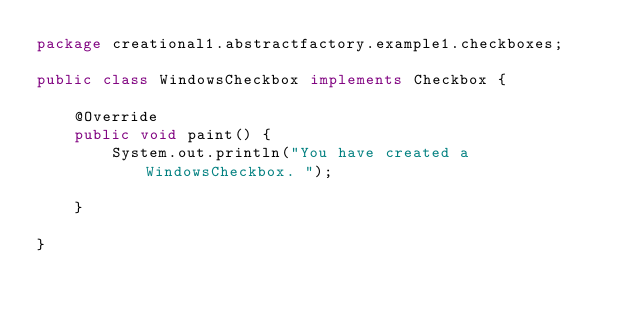Convert code to text. <code><loc_0><loc_0><loc_500><loc_500><_Java_>package creational1.abstractfactory.example1.checkboxes;

public class WindowsCheckbox implements Checkbox {

	@Override
	public void paint() {
		System.out.println("You have created a WindowsCheckbox. ");
		
	}

}
</code> 